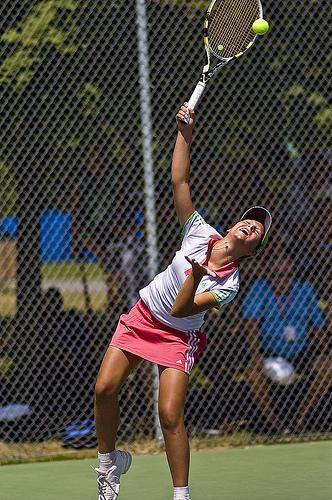Identify the color of the woman's skirt and the detail on it. The woman's skirt is pink and white with an Adidas logo. What type of shirt is the girl wearing? The girl is wearing a T-shirt. What is the woman holding in her hand? The woman is holding a tennis racquet in her hand. List three objects that are part of the tennis court. Tennis ball, woman's black and yellow racket, and part of the tennis court. What kind of shoe is the woman wearing in the image? The woman is wearing a white tennis shoe. Briefly describe the background of the image. The background consists of a tennis court, chain link fence and a blue wall. How many people are visible in the image? Two people are visible, a man and a woman. What is the color of the tennis ball in the image? The tennis ball is green. 